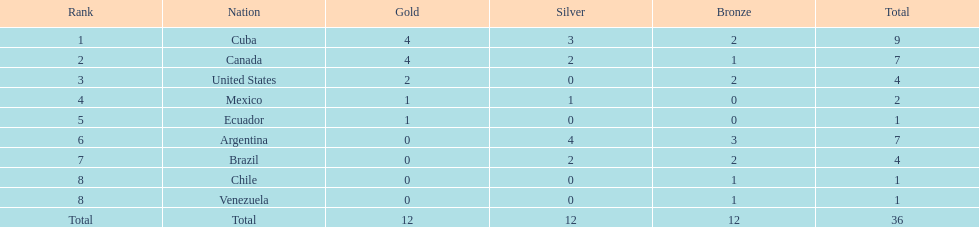Which ranking is mexico? 4. 